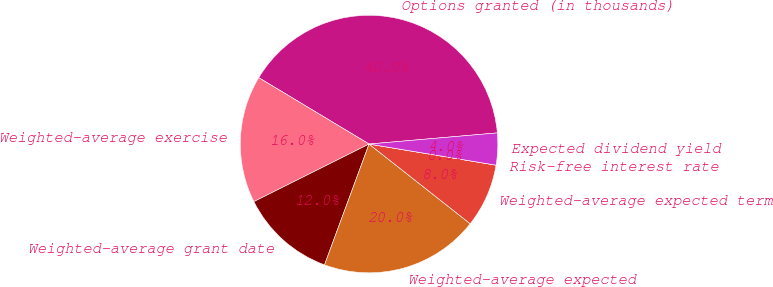Convert chart. <chart><loc_0><loc_0><loc_500><loc_500><pie_chart><fcel>Options granted (in thousands)<fcel>Weighted-average exercise<fcel>Weighted-average grant date<fcel>Weighted-average expected<fcel>Weighted-average expected term<fcel>Risk-free interest rate<fcel>Expected dividend yield<nl><fcel>40.0%<fcel>16.0%<fcel>12.0%<fcel>20.0%<fcel>8.0%<fcel>0.0%<fcel>4.0%<nl></chart> 